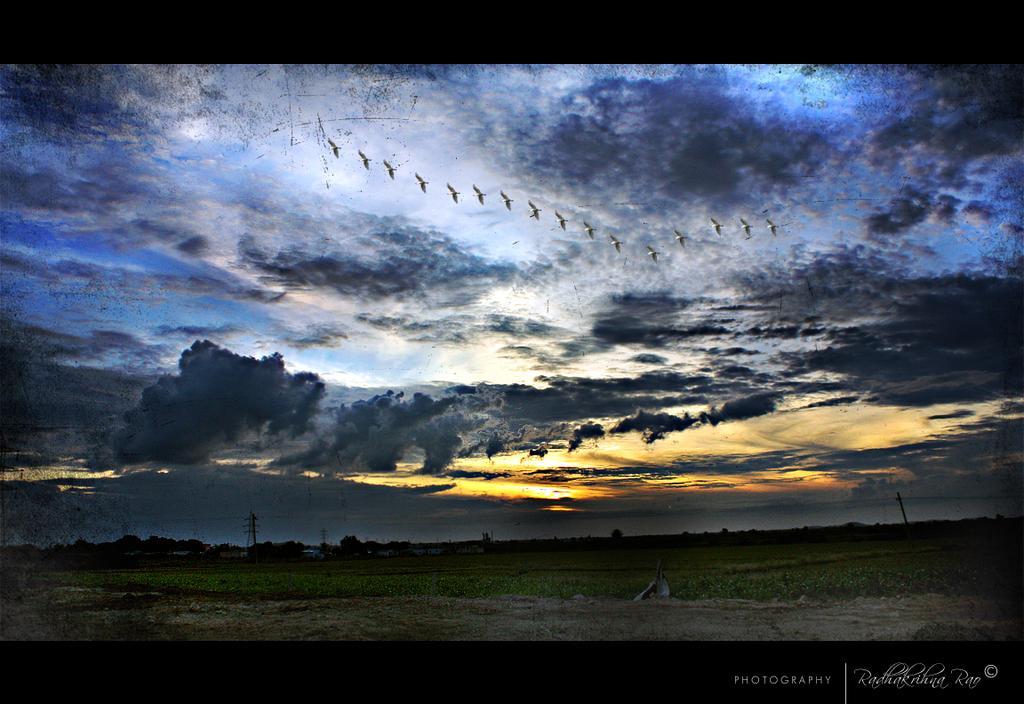Describe this image in one or two sentences. In this image, we can see a crop. There are clouds and boats in the sky. There is a text in the bottom right of the image. 